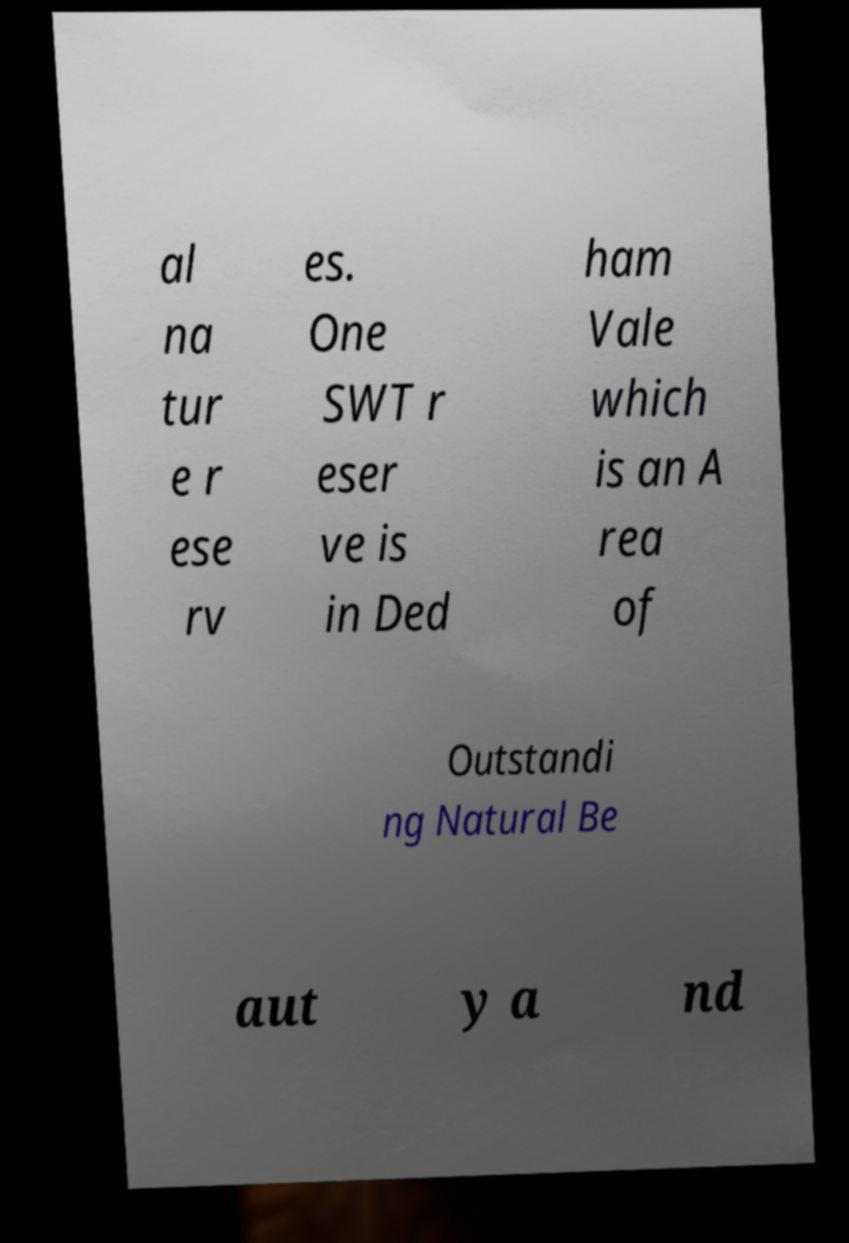Could you extract and type out the text from this image? al na tur e r ese rv es. One SWT r eser ve is in Ded ham Vale which is an A rea of Outstandi ng Natural Be aut y a nd 